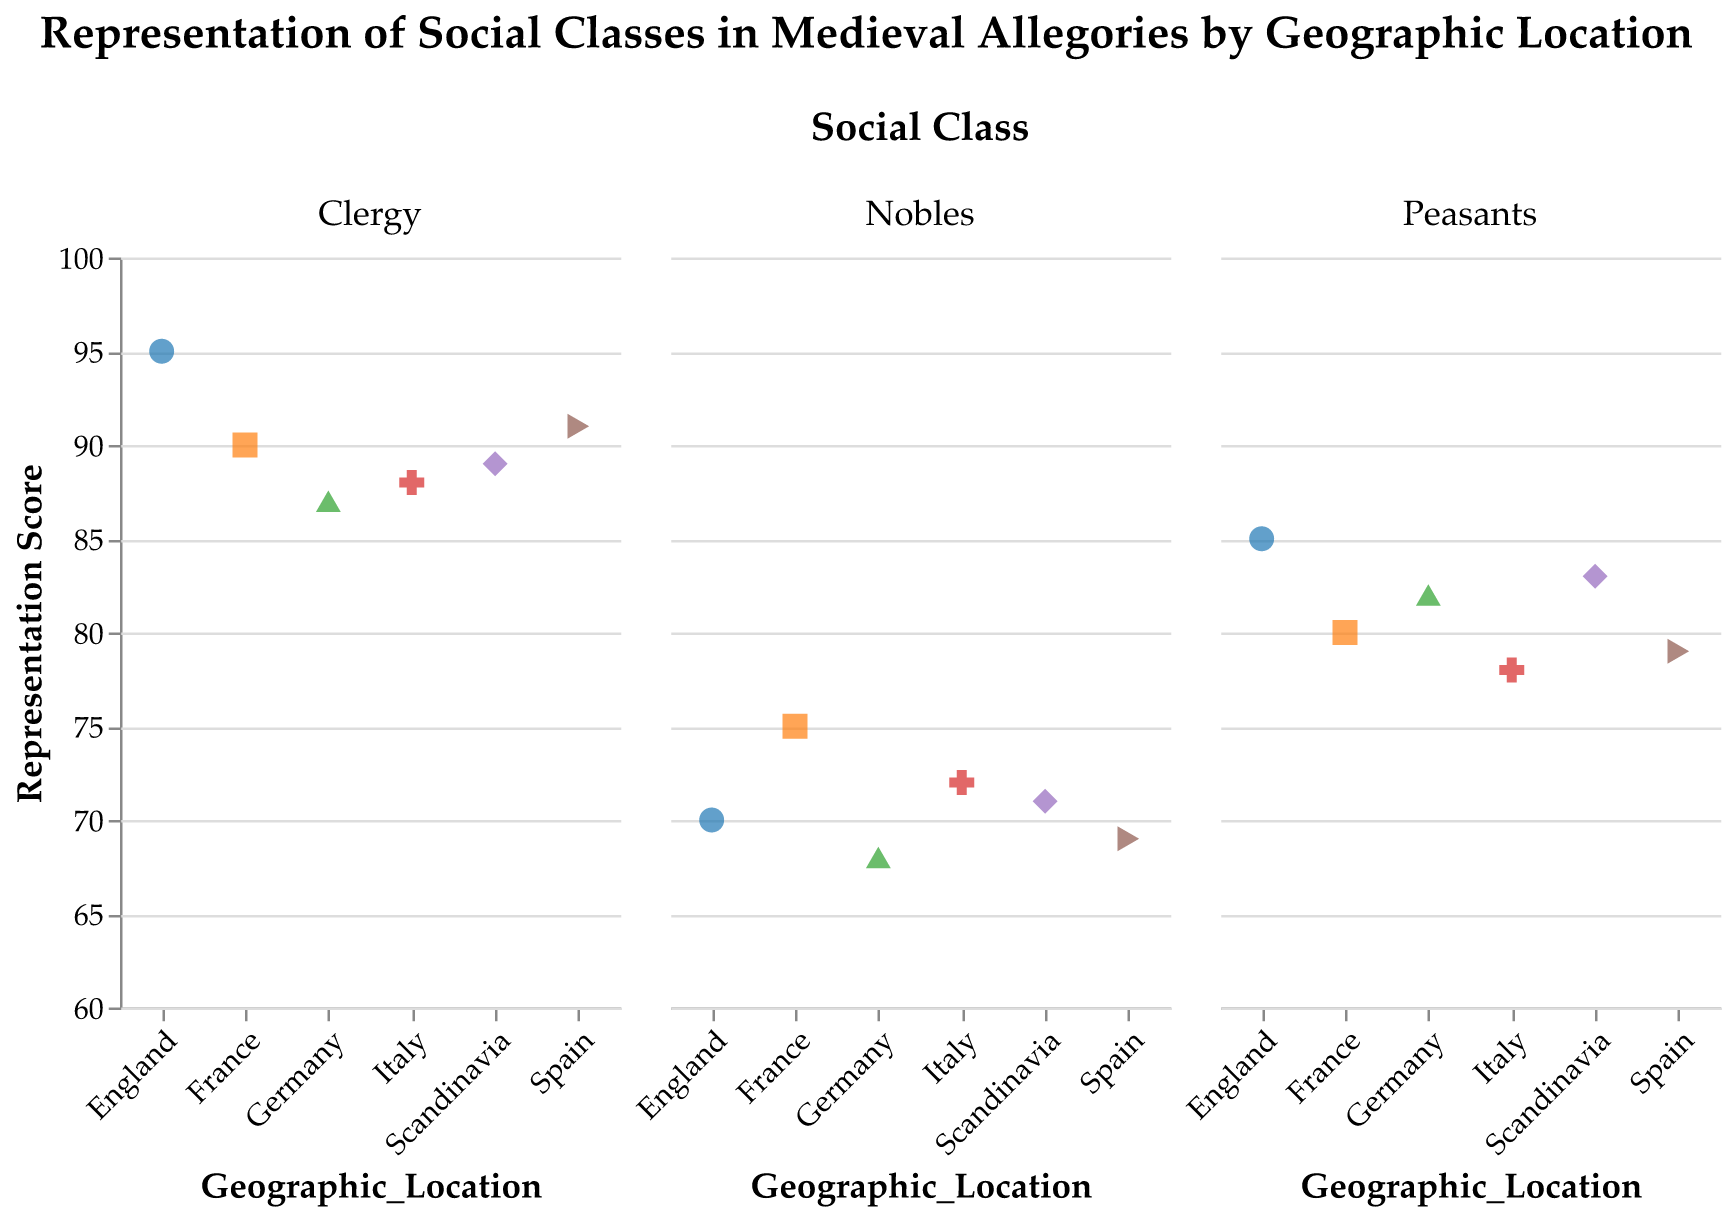How many geographic locations are represented in the plot? Identify the number of unique geographic locations labeled on the x-axis. The plot shows data points for six geographic locations.
Answer: Six Which social class has the highest representation score in Italy? Look at the subplot for Italy and compare the representation scores of the social classes. The clergy class in Italy has the highest representation score of 88.
Answer: Clergy What is the average representation score for social class Clergy across all locations? Sum the representation scores for the clergy class across all locations and divide by the number of locations (95+90+88+87+91+89)/6. This calculation results in an average score of 90.
Answer: 90 Which social class tends to have the lowest representation across all locations? Compare the scores of each social class and find the one with the most consistently low scores. Nobles often have lower representation scores compared to peasants and clergy.
Answer: Nobles What is the largest difference in representation score between any two social classes within the same geographic location? Calculate the differences within each location: 
England (Clergy-Peasants): 95-85=10, 
France (Clergy-Peasants): 90-80=10, 
Italy (Clergy-Peasants): 88-78=10, 
Germany (Clergy-Peasants): 87-82=5, 
Spain (Clergy-Peasants): 91-79=12, 
Scandinavia (Clergy-Peasants): 89-83=6. The largest difference is in Spain between Clergy and Peasants.
Answer: 12 How does the representation score of peasants in France compare to that in England? Look at the scores for peasants in France and England. France has a score of 80, and England has a score of 85, showing that France's score is 5 points lower than England's.
Answer: France is 5 points lower Which geographic location has the highest average representation score across all social classes? Calculate the average scores for each location: 
England: (85+70+95)/3=83.33, 
France: (80+75+90)/3=81.67, 
Italy: (78+72+88)/3=79.33, 
Germany: (82+68+87)/3=79, 
Spain: (79+69+91)/3=79.67, 
Scandinavia: (83+71+89)/3=81.00. 
England has the highest average score.
Answer: England 